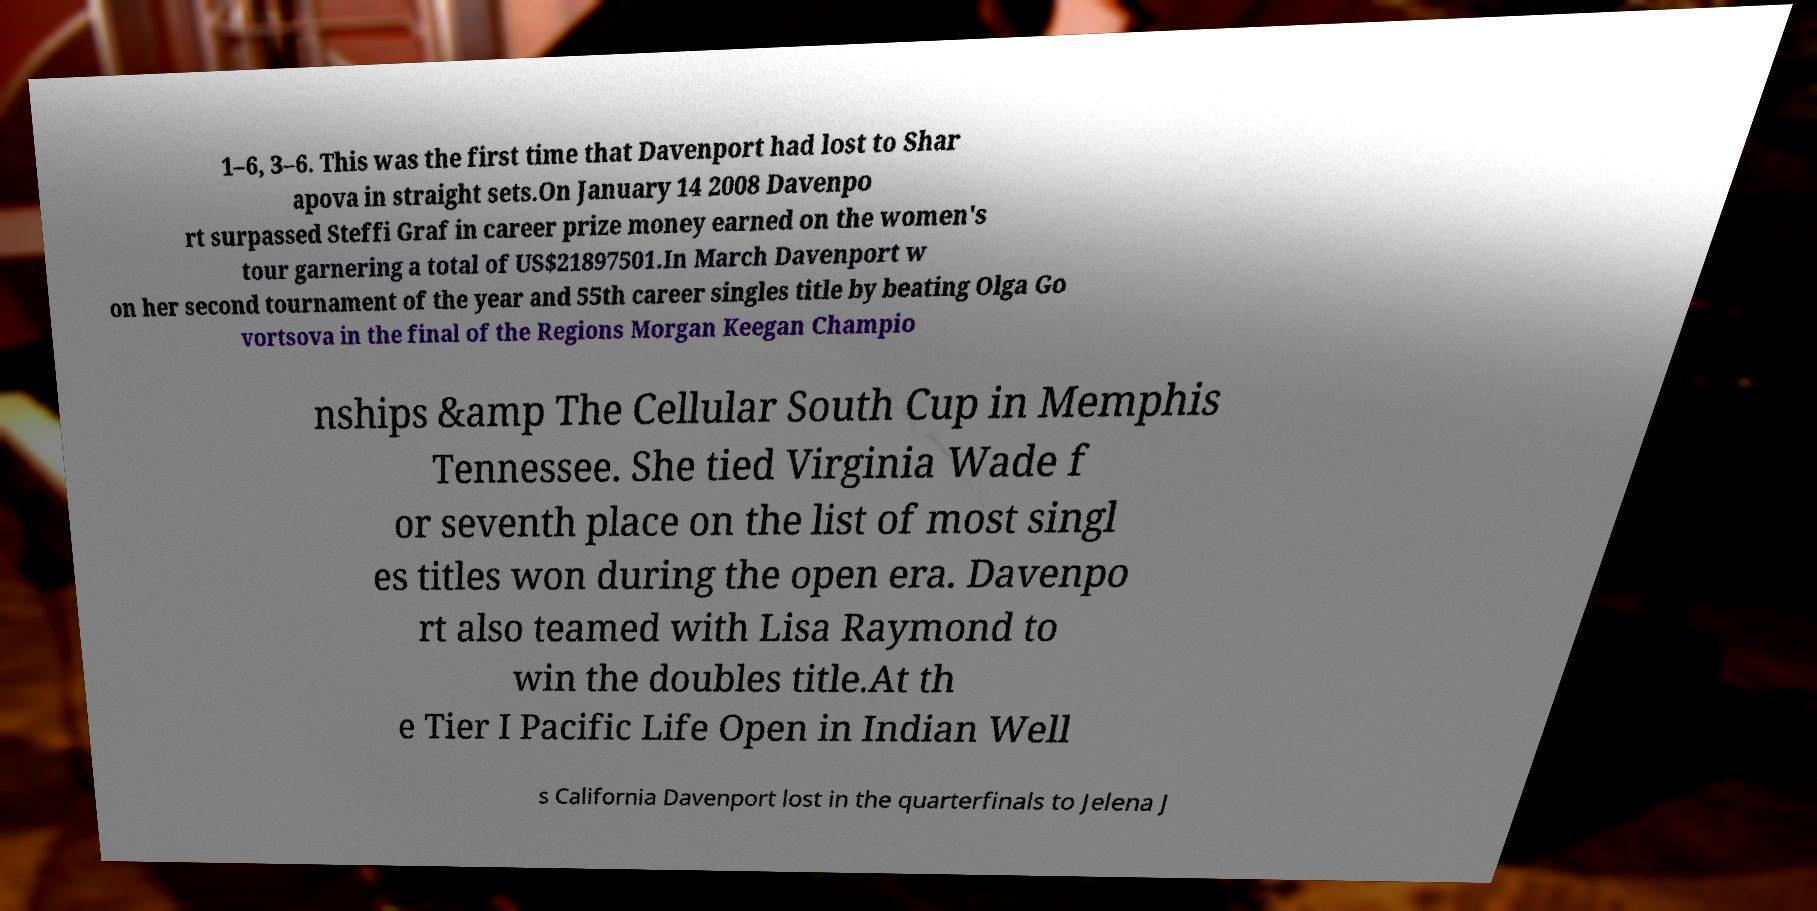What messages or text are displayed in this image? I need them in a readable, typed format. 1–6, 3–6. This was the first time that Davenport had lost to Shar apova in straight sets.On January 14 2008 Davenpo rt surpassed Steffi Graf in career prize money earned on the women's tour garnering a total of US$21897501.In March Davenport w on her second tournament of the year and 55th career singles title by beating Olga Go vortsova in the final of the Regions Morgan Keegan Champio nships &amp The Cellular South Cup in Memphis Tennessee. She tied Virginia Wade f or seventh place on the list of most singl es titles won during the open era. Davenpo rt also teamed with Lisa Raymond to win the doubles title.At th e Tier I Pacific Life Open in Indian Well s California Davenport lost in the quarterfinals to Jelena J 